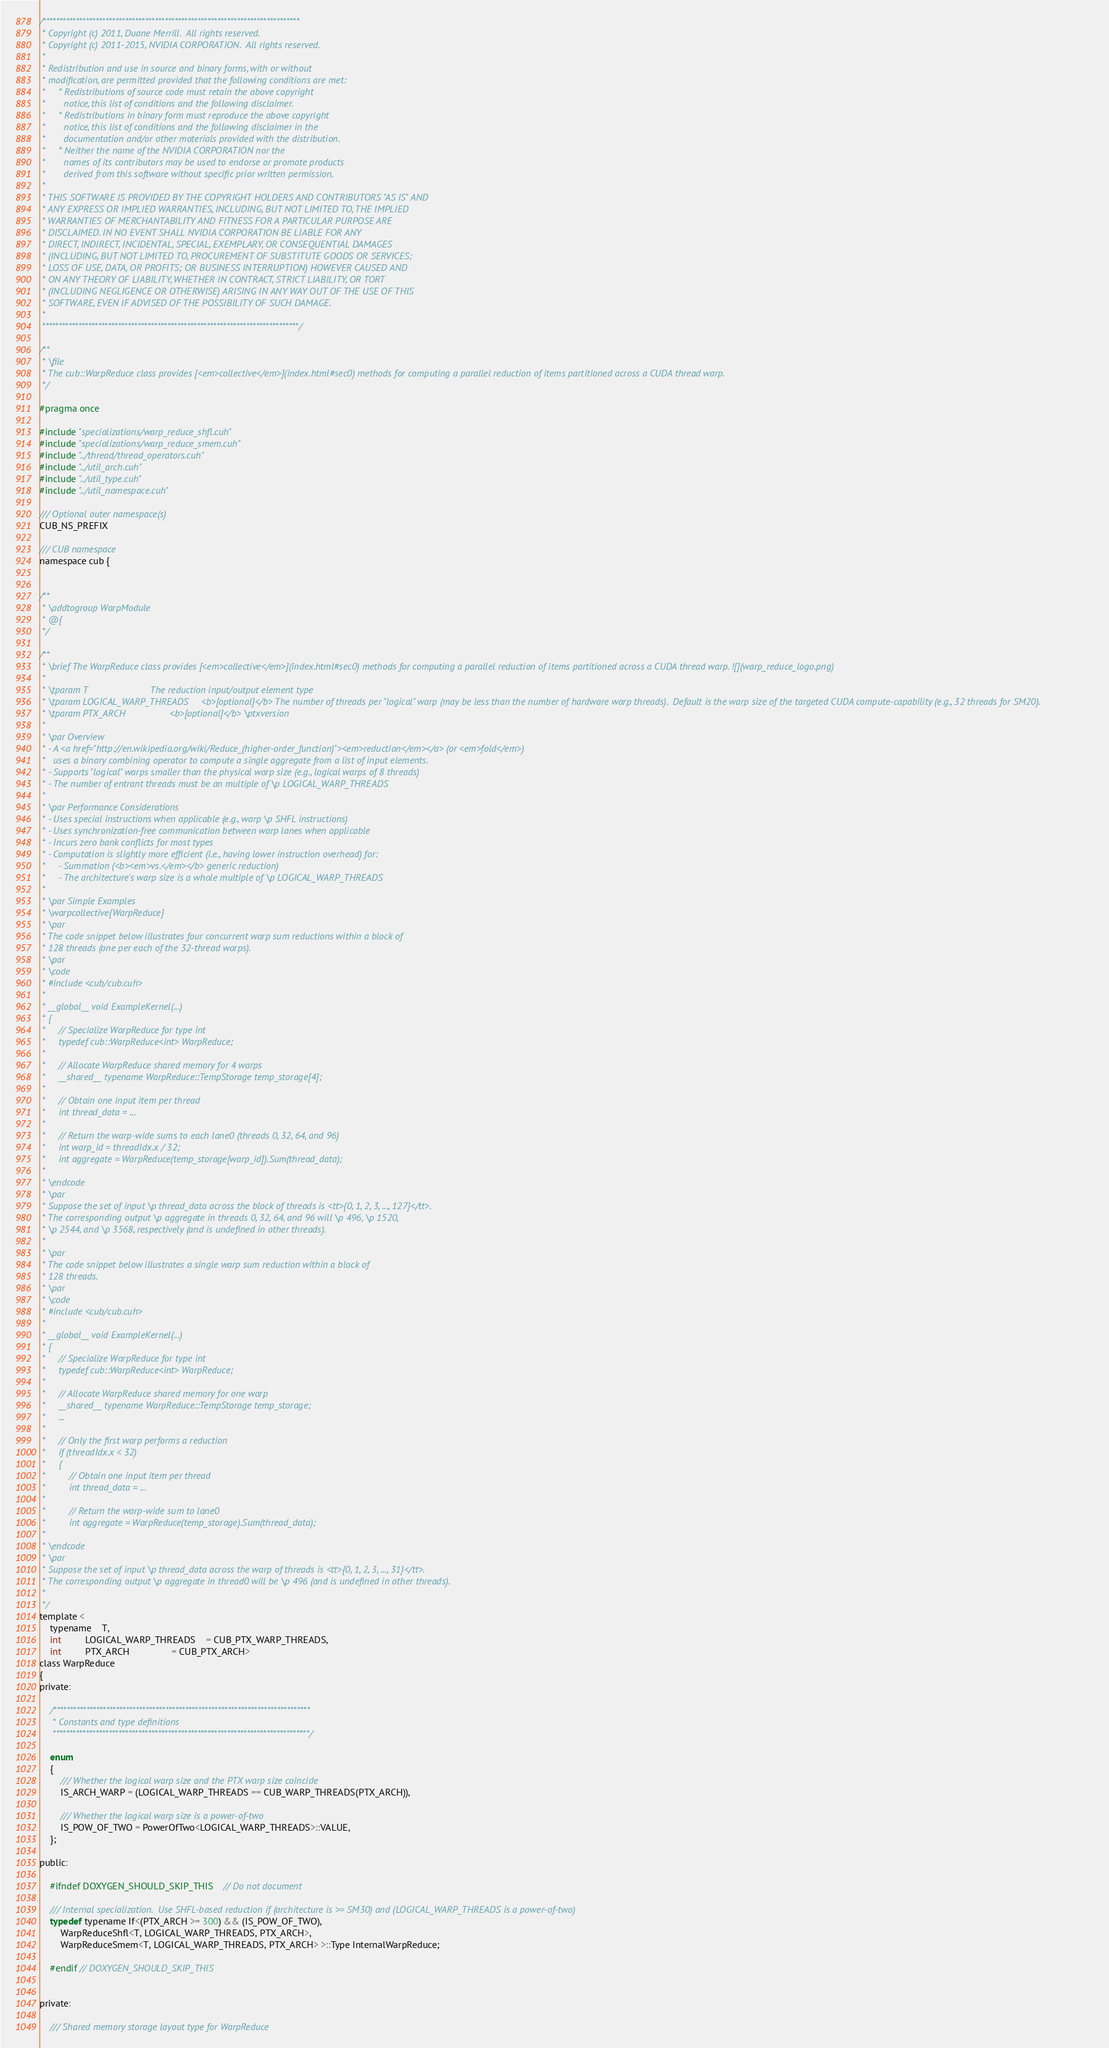<code> <loc_0><loc_0><loc_500><loc_500><_Cuda_>/******************************************************************************
 * Copyright (c) 2011, Duane Merrill.  All rights reserved.
 * Copyright (c) 2011-2015, NVIDIA CORPORATION.  All rights reserved.
 * 
 * Redistribution and use in source and binary forms, with or without
 * modification, are permitted provided that the following conditions are met:
 *     * Redistributions of source code must retain the above copyright
 *       notice, this list of conditions and the following disclaimer.
 *     * Redistributions in binary form must reproduce the above copyright
 *       notice, this list of conditions and the following disclaimer in the
 *       documentation and/or other materials provided with the distribution.
 *     * Neither the name of the NVIDIA CORPORATION nor the
 *       names of its contributors may be used to endorse or promote products
 *       derived from this software without specific prior written permission.
 * 
 * THIS SOFTWARE IS PROVIDED BY THE COPYRIGHT HOLDERS AND CONTRIBUTORS "AS IS" AND
 * ANY EXPRESS OR IMPLIED WARRANTIES, INCLUDING, BUT NOT LIMITED TO, THE IMPLIED
 * WARRANTIES OF MERCHANTABILITY AND FITNESS FOR A PARTICULAR PURPOSE ARE
 * DISCLAIMED. IN NO EVENT SHALL NVIDIA CORPORATION BE LIABLE FOR ANY
 * DIRECT, INDIRECT, INCIDENTAL, SPECIAL, EXEMPLARY, OR CONSEQUENTIAL DAMAGES
 * (INCLUDING, BUT NOT LIMITED TO, PROCUREMENT OF SUBSTITUTE GOODS OR SERVICES;
 * LOSS OF USE, DATA, OR PROFITS; OR BUSINESS INTERRUPTION) HOWEVER CAUSED AND
 * ON ANY THEORY OF LIABILITY, WHETHER IN CONTRACT, STRICT LIABILITY, OR TORT
 * (INCLUDING NEGLIGENCE OR OTHERWISE) ARISING IN ANY WAY OUT OF THE USE OF THIS
 * SOFTWARE, EVEN IF ADVISED OF THE POSSIBILITY OF SUCH DAMAGE.
 *
 ******************************************************************************/

/**
 * \file
 * The cub::WarpReduce class provides [<em>collective</em>](index.html#sec0) methods for computing a parallel reduction of items partitioned across a CUDA thread warp.
 */

#pragma once

#include "specializations/warp_reduce_shfl.cuh"
#include "specializations/warp_reduce_smem.cuh"
#include "../thread/thread_operators.cuh"
#include "../util_arch.cuh"
#include "../util_type.cuh"
#include "../util_namespace.cuh"

/// Optional outer namespace(s)
CUB_NS_PREFIX

/// CUB namespace
namespace cub {


/**
 * \addtogroup WarpModule
 * @{
 */

/**
 * \brief The WarpReduce class provides [<em>collective</em>](index.html#sec0) methods for computing a parallel reduction of items partitioned across a CUDA thread warp. ![](warp_reduce_logo.png)
 *
 * \tparam T                        The reduction input/output element type
 * \tparam LOGICAL_WARP_THREADS     <b>[optional]</b> The number of threads per "logical" warp (may be less than the number of hardware warp threads).  Default is the warp size of the targeted CUDA compute-capability (e.g., 32 threads for SM20).
 * \tparam PTX_ARCH                 <b>[optional]</b> \ptxversion
 *
 * \par Overview
 * - A <a href="http://en.wikipedia.org/wiki/Reduce_(higher-order_function)"><em>reduction</em></a> (or <em>fold</em>)
 *   uses a binary combining operator to compute a single aggregate from a list of input elements.
 * - Supports "logical" warps smaller than the physical warp size (e.g., logical warps of 8 threads)
 * - The number of entrant threads must be an multiple of \p LOGICAL_WARP_THREADS
 *
 * \par Performance Considerations
 * - Uses special instructions when applicable (e.g., warp \p SHFL instructions)
 * - Uses synchronization-free communication between warp lanes when applicable
 * - Incurs zero bank conflicts for most types
 * - Computation is slightly more efficient (i.e., having lower instruction overhead) for:
 *     - Summation (<b><em>vs.</em></b> generic reduction)
 *     - The architecture's warp size is a whole multiple of \p LOGICAL_WARP_THREADS
 *
 * \par Simple Examples
 * \warpcollective{WarpReduce}
 * \par
 * The code snippet below illustrates four concurrent warp sum reductions within a block of
 * 128 threads (one per each of the 32-thread warps).
 * \par
 * \code
 * #include <cub/cub.cuh>
 *
 * __global__ void ExampleKernel(...)
 * {
 *     // Specialize WarpReduce for type int
 *     typedef cub::WarpReduce<int> WarpReduce;
 *
 *     // Allocate WarpReduce shared memory for 4 warps
 *     __shared__ typename WarpReduce::TempStorage temp_storage[4];
 *
 *     // Obtain one input item per thread
 *     int thread_data = ...
 *
 *     // Return the warp-wide sums to each lane0 (threads 0, 32, 64, and 96)
 *     int warp_id = threadIdx.x / 32;
 *     int aggregate = WarpReduce(temp_storage[warp_id]).Sum(thread_data);
 *
 * \endcode
 * \par
 * Suppose the set of input \p thread_data across the block of threads is <tt>{0, 1, 2, 3, ..., 127}</tt>.
 * The corresponding output \p aggregate in threads 0, 32, 64, and 96 will \p 496, \p 1520,
 * \p 2544, and \p 3568, respectively (and is undefined in other threads).
 *
 * \par
 * The code snippet below illustrates a single warp sum reduction within a block of
 * 128 threads.
 * \par
 * \code
 * #include <cub/cub.cuh>
 *
 * __global__ void ExampleKernel(...)
 * {
 *     // Specialize WarpReduce for type int
 *     typedef cub::WarpReduce<int> WarpReduce;
 *
 *     // Allocate WarpReduce shared memory for one warp
 *     __shared__ typename WarpReduce::TempStorage temp_storage;
 *     ...
 *
 *     // Only the first warp performs a reduction
 *     if (threadIdx.x < 32)
 *     {
 *         // Obtain one input item per thread
 *         int thread_data = ...
 *
 *         // Return the warp-wide sum to lane0
 *         int aggregate = WarpReduce(temp_storage).Sum(thread_data);
 *
 * \endcode
 * \par
 * Suppose the set of input \p thread_data across the warp of threads is <tt>{0, 1, 2, 3, ..., 31}</tt>.
 * The corresponding output \p aggregate in thread0 will be \p 496 (and is undefined in other threads).
 *
 */
template <
    typename    T,
    int         LOGICAL_WARP_THREADS    = CUB_PTX_WARP_THREADS,
    int         PTX_ARCH                = CUB_PTX_ARCH>
class WarpReduce
{
private:

    /******************************************************************************
     * Constants and type definitions
     ******************************************************************************/

    enum
    {
        /// Whether the logical warp size and the PTX warp size coincide
        IS_ARCH_WARP = (LOGICAL_WARP_THREADS == CUB_WARP_THREADS(PTX_ARCH)),

        /// Whether the logical warp size is a power-of-two
        IS_POW_OF_TWO = PowerOfTwo<LOGICAL_WARP_THREADS>::VALUE,
    };

public:

    #ifndef DOXYGEN_SHOULD_SKIP_THIS    // Do not document

    /// Internal specialization.  Use SHFL-based reduction if (architecture is >= SM30) and (LOGICAL_WARP_THREADS is a power-of-two)
    typedef typename If<(PTX_ARCH >= 300) && (IS_POW_OF_TWO),
        WarpReduceShfl<T, LOGICAL_WARP_THREADS, PTX_ARCH>,
        WarpReduceSmem<T, LOGICAL_WARP_THREADS, PTX_ARCH> >::Type InternalWarpReduce;

    #endif // DOXYGEN_SHOULD_SKIP_THIS


private:

    /// Shared memory storage layout type for WarpReduce</code> 